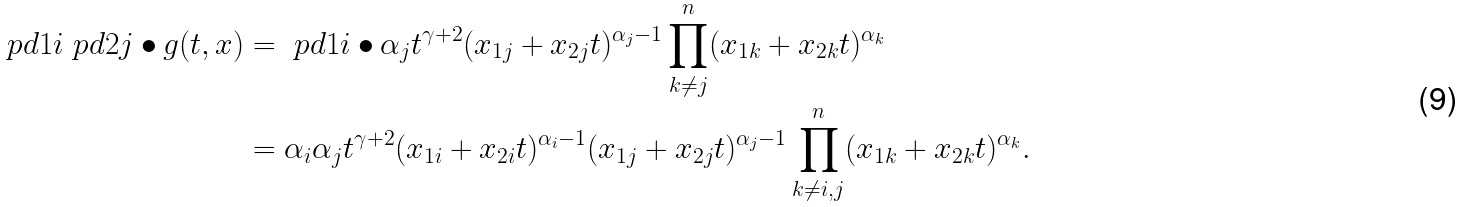<formula> <loc_0><loc_0><loc_500><loc_500>\ p d { 1 i } \ p d { 2 j } \bullet g ( t , x ) & = \ p d { 1 i } \bullet \alpha _ { j } t ^ { \gamma + 2 } ( x _ { 1 j } + x _ { 2 j } t ) ^ { \alpha _ { j } - 1 } \prod _ { k \ne j } ^ { n } ( x _ { 1 k } + x _ { 2 k } t ) ^ { \alpha _ { k } } \\ & = \alpha _ { i } \alpha _ { j } t ^ { \gamma + 2 } ( x _ { 1 i } + x _ { 2 i } t ) ^ { \alpha _ { i } - 1 } ( x _ { 1 j } + x _ { 2 j } t ) ^ { \alpha _ { j } - 1 } \prod _ { k \ne i , j } ^ { n } ( x _ { 1 k } + x _ { 2 k } t ) ^ { \alpha _ { k } } .</formula> 